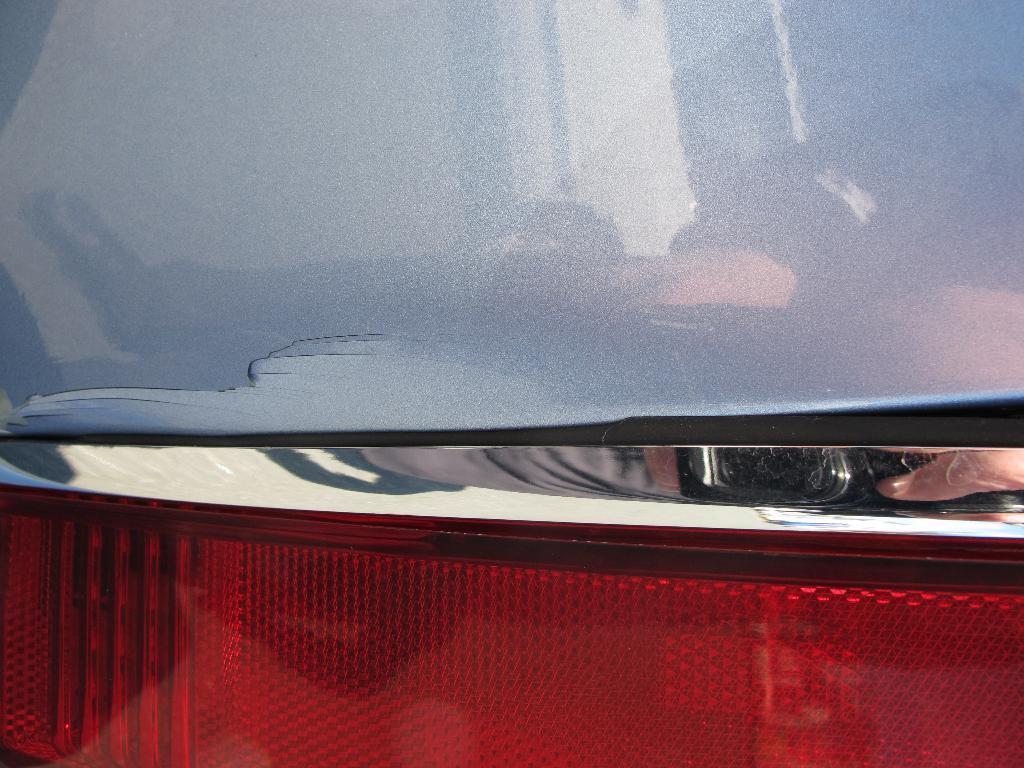Could you give a brief overview of what you see in this image? In this image we can see an object which looks like a vehicle, at the bottom of the image we can see the light, also we can see the reflection of the fingers of a person on the vehicle. 